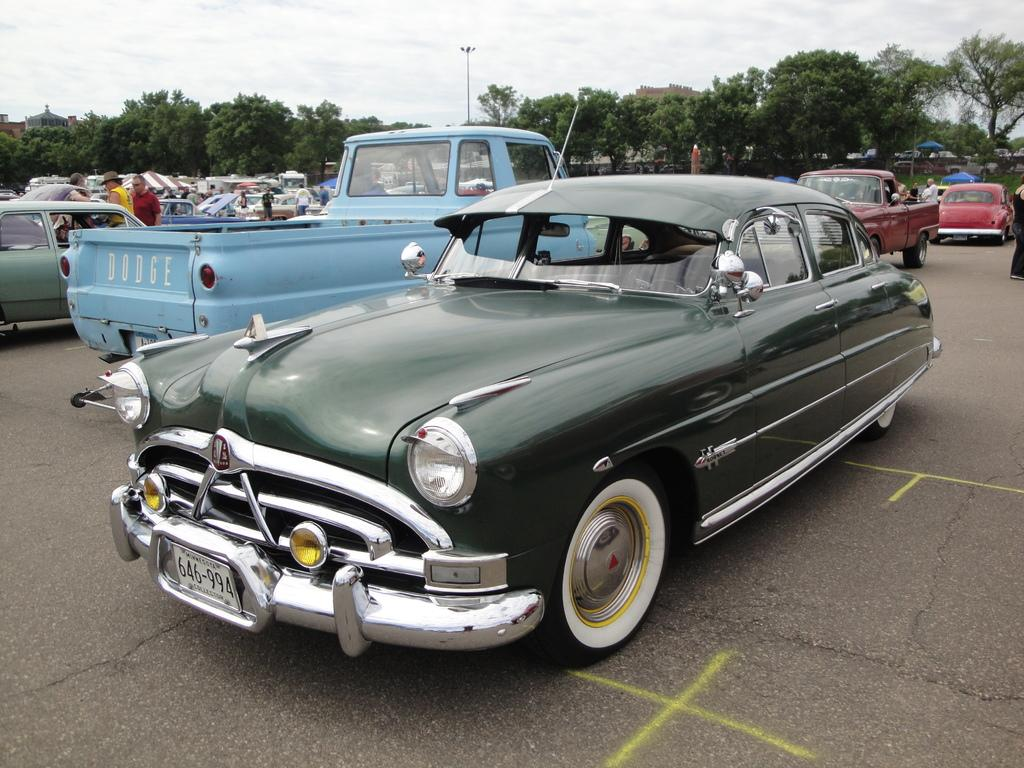What is happening on the road in the image? There are vehicles, people standing, and people walking on the road in the image. What can be seen in the background of the image? There are trees, poles, buildings, and tents in the background. What is visible in the sky in the image? There are clouds in the sky in the image. What type of drink is being served in the tents in the image? There is no indication of any drinks or tents serving drinks in the image. How many frogs can be seen hopping on the road in the image? There are no frogs present in the image. 